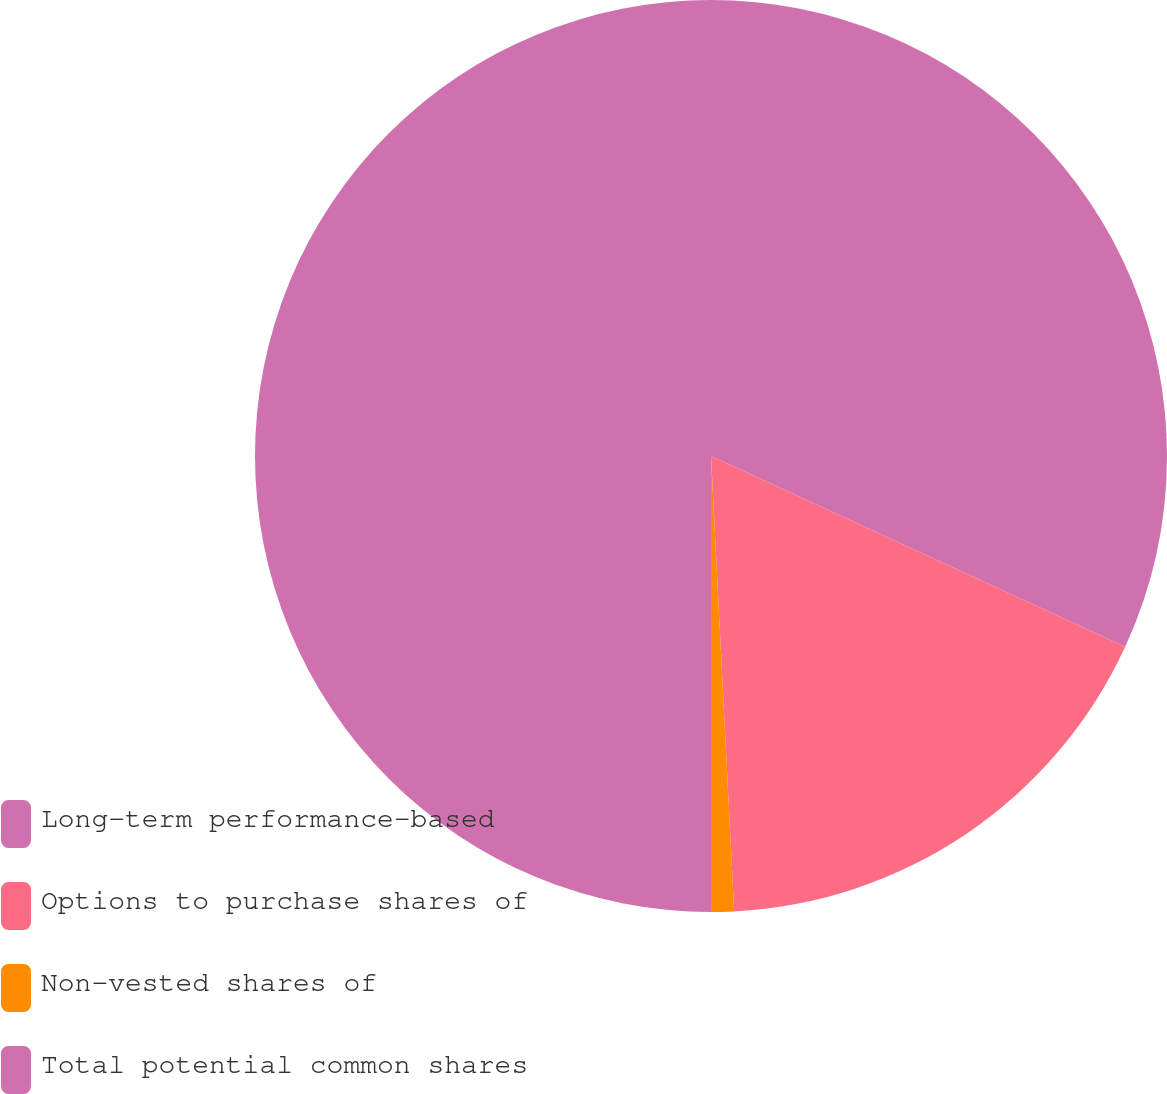<chart> <loc_0><loc_0><loc_500><loc_500><pie_chart><fcel>Long-term performance-based<fcel>Options to purchase shares of<fcel>Non-vested shares of<fcel>Total potential common shares<nl><fcel>31.87%<fcel>17.32%<fcel>0.81%<fcel>50.0%<nl></chart> 